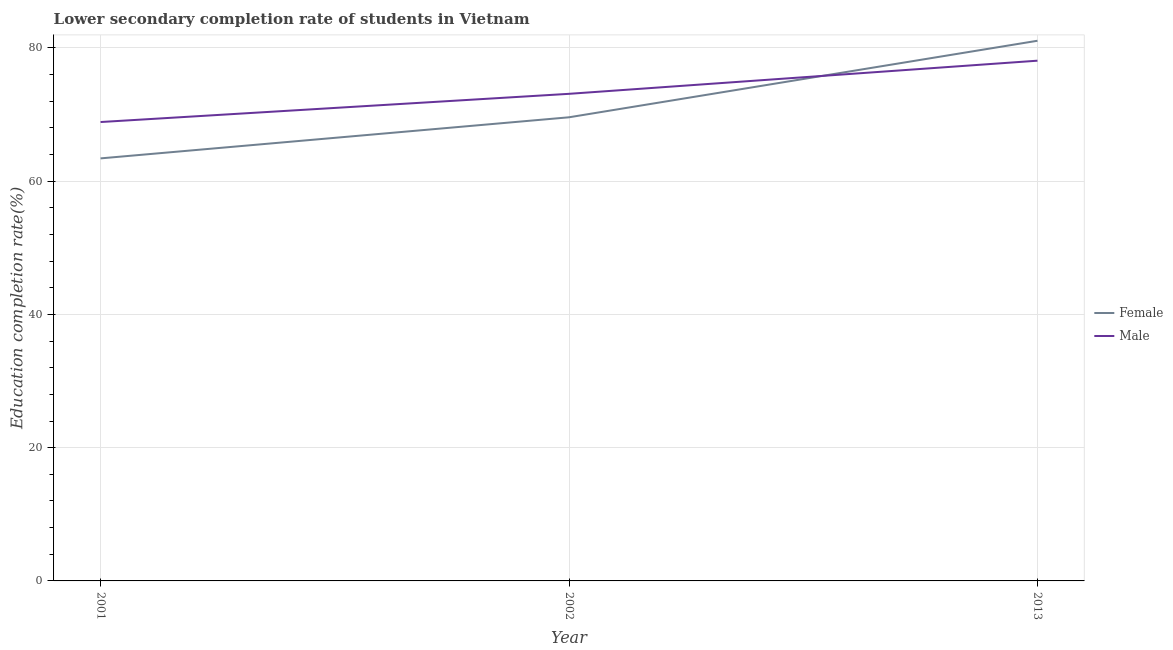How many different coloured lines are there?
Provide a succinct answer. 2. Does the line corresponding to education completion rate of female students intersect with the line corresponding to education completion rate of male students?
Keep it short and to the point. Yes. What is the education completion rate of female students in 2002?
Keep it short and to the point. 69.59. Across all years, what is the maximum education completion rate of male students?
Your answer should be very brief. 78.08. Across all years, what is the minimum education completion rate of female students?
Keep it short and to the point. 63.42. In which year was the education completion rate of female students minimum?
Your answer should be compact. 2001. What is the total education completion rate of female students in the graph?
Provide a short and direct response. 214.09. What is the difference between the education completion rate of male students in 2002 and that in 2013?
Offer a terse response. -4.97. What is the difference between the education completion rate of female students in 2013 and the education completion rate of male students in 2002?
Give a very brief answer. 7.97. What is the average education completion rate of female students per year?
Give a very brief answer. 71.36. In the year 2001, what is the difference between the education completion rate of male students and education completion rate of female students?
Keep it short and to the point. 5.46. In how many years, is the education completion rate of female students greater than 24 %?
Your answer should be compact. 3. What is the ratio of the education completion rate of male students in 2002 to that in 2013?
Give a very brief answer. 0.94. What is the difference between the highest and the second highest education completion rate of male students?
Ensure brevity in your answer.  4.97. What is the difference between the highest and the lowest education completion rate of female students?
Make the answer very short. 17.66. Does the education completion rate of female students monotonically increase over the years?
Your answer should be compact. Yes. Is the education completion rate of female students strictly greater than the education completion rate of male students over the years?
Make the answer very short. No. How many lines are there?
Your answer should be very brief. 2. Does the graph contain grids?
Keep it short and to the point. Yes. How many legend labels are there?
Your response must be concise. 2. What is the title of the graph?
Ensure brevity in your answer.  Lower secondary completion rate of students in Vietnam. What is the label or title of the X-axis?
Provide a succinct answer. Year. What is the label or title of the Y-axis?
Your answer should be very brief. Education completion rate(%). What is the Education completion rate(%) in Female in 2001?
Offer a terse response. 63.42. What is the Education completion rate(%) of Male in 2001?
Provide a succinct answer. 68.88. What is the Education completion rate(%) of Female in 2002?
Offer a very short reply. 69.59. What is the Education completion rate(%) in Male in 2002?
Ensure brevity in your answer.  73.11. What is the Education completion rate(%) of Female in 2013?
Make the answer very short. 81.08. What is the Education completion rate(%) of Male in 2013?
Provide a succinct answer. 78.08. Across all years, what is the maximum Education completion rate(%) in Female?
Provide a succinct answer. 81.08. Across all years, what is the maximum Education completion rate(%) in Male?
Provide a succinct answer. 78.08. Across all years, what is the minimum Education completion rate(%) of Female?
Provide a succinct answer. 63.42. Across all years, what is the minimum Education completion rate(%) in Male?
Offer a terse response. 68.88. What is the total Education completion rate(%) in Female in the graph?
Provide a short and direct response. 214.09. What is the total Education completion rate(%) in Male in the graph?
Give a very brief answer. 220.07. What is the difference between the Education completion rate(%) of Female in 2001 and that in 2002?
Keep it short and to the point. -6.17. What is the difference between the Education completion rate(%) in Male in 2001 and that in 2002?
Your response must be concise. -4.23. What is the difference between the Education completion rate(%) of Female in 2001 and that in 2013?
Offer a very short reply. -17.66. What is the difference between the Education completion rate(%) in Male in 2001 and that in 2013?
Your response must be concise. -9.21. What is the difference between the Education completion rate(%) in Female in 2002 and that in 2013?
Offer a terse response. -11.49. What is the difference between the Education completion rate(%) of Male in 2002 and that in 2013?
Your answer should be compact. -4.97. What is the difference between the Education completion rate(%) of Female in 2001 and the Education completion rate(%) of Male in 2002?
Provide a succinct answer. -9.69. What is the difference between the Education completion rate(%) in Female in 2001 and the Education completion rate(%) in Male in 2013?
Your response must be concise. -14.66. What is the difference between the Education completion rate(%) in Female in 2002 and the Education completion rate(%) in Male in 2013?
Keep it short and to the point. -8.49. What is the average Education completion rate(%) in Female per year?
Ensure brevity in your answer.  71.36. What is the average Education completion rate(%) in Male per year?
Your response must be concise. 73.36. In the year 2001, what is the difference between the Education completion rate(%) of Female and Education completion rate(%) of Male?
Your response must be concise. -5.46. In the year 2002, what is the difference between the Education completion rate(%) of Female and Education completion rate(%) of Male?
Give a very brief answer. -3.52. In the year 2013, what is the difference between the Education completion rate(%) of Female and Education completion rate(%) of Male?
Your answer should be compact. 2.99. What is the ratio of the Education completion rate(%) in Female in 2001 to that in 2002?
Keep it short and to the point. 0.91. What is the ratio of the Education completion rate(%) of Male in 2001 to that in 2002?
Give a very brief answer. 0.94. What is the ratio of the Education completion rate(%) of Female in 2001 to that in 2013?
Your answer should be compact. 0.78. What is the ratio of the Education completion rate(%) of Male in 2001 to that in 2013?
Make the answer very short. 0.88. What is the ratio of the Education completion rate(%) of Female in 2002 to that in 2013?
Give a very brief answer. 0.86. What is the ratio of the Education completion rate(%) in Male in 2002 to that in 2013?
Make the answer very short. 0.94. What is the difference between the highest and the second highest Education completion rate(%) of Female?
Ensure brevity in your answer.  11.49. What is the difference between the highest and the second highest Education completion rate(%) of Male?
Your response must be concise. 4.97. What is the difference between the highest and the lowest Education completion rate(%) of Female?
Make the answer very short. 17.66. What is the difference between the highest and the lowest Education completion rate(%) in Male?
Give a very brief answer. 9.21. 